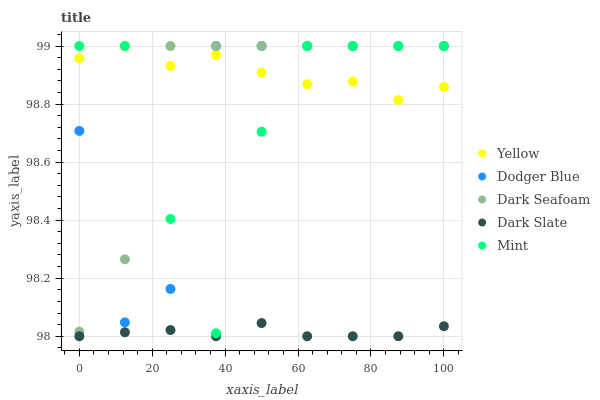Does Dark Slate have the minimum area under the curve?
Answer yes or no. Yes. Does Yellow have the maximum area under the curve?
Answer yes or no. Yes. Does Dark Seafoam have the minimum area under the curve?
Answer yes or no. No. Does Dark Seafoam have the maximum area under the curve?
Answer yes or no. No. Is Dark Slate the smoothest?
Answer yes or no. Yes. Is Mint the roughest?
Answer yes or no. Yes. Is Dark Seafoam the smoothest?
Answer yes or no. No. Is Dark Seafoam the roughest?
Answer yes or no. No. Does Dark Slate have the lowest value?
Answer yes or no. Yes. Does Dark Seafoam have the lowest value?
Answer yes or no. No. Does Yellow have the highest value?
Answer yes or no. Yes. Is Dark Slate less than Dark Seafoam?
Answer yes or no. Yes. Is Dark Seafoam greater than Dark Slate?
Answer yes or no. Yes. Does Mint intersect Dodger Blue?
Answer yes or no. Yes. Is Mint less than Dodger Blue?
Answer yes or no. No. Is Mint greater than Dodger Blue?
Answer yes or no. No. Does Dark Slate intersect Dark Seafoam?
Answer yes or no. No. 